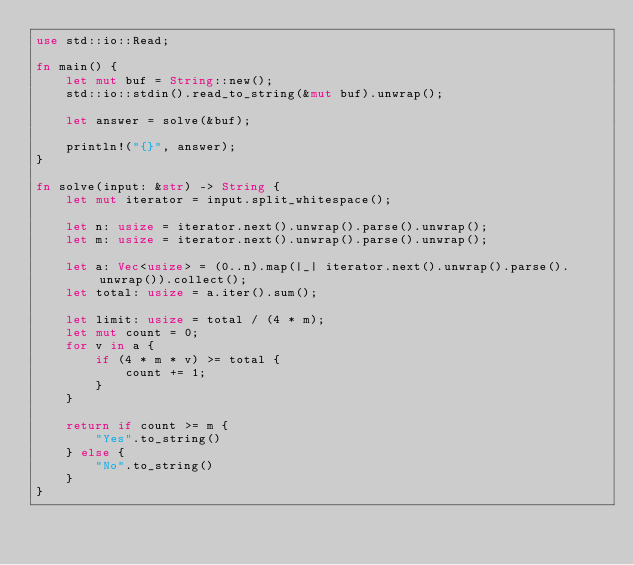Convert code to text. <code><loc_0><loc_0><loc_500><loc_500><_Rust_>use std::io::Read;

fn main() {
    let mut buf = String::new();
    std::io::stdin().read_to_string(&mut buf).unwrap();

    let answer = solve(&buf);

    println!("{}", answer);
}

fn solve(input: &str) -> String {
    let mut iterator = input.split_whitespace();

    let n: usize = iterator.next().unwrap().parse().unwrap();
    let m: usize = iterator.next().unwrap().parse().unwrap();

    let a: Vec<usize> = (0..n).map(|_| iterator.next().unwrap().parse().unwrap()).collect();
    let total: usize = a.iter().sum();

    let limit: usize = total / (4 * m);
    let mut count = 0;
    for v in a {
        if (4 * m * v) >= total {
            count += 1;
        }
    }

    return if count >= m {
        "Yes".to_string()
    } else {
        "No".to_string()
    }
}
</code> 